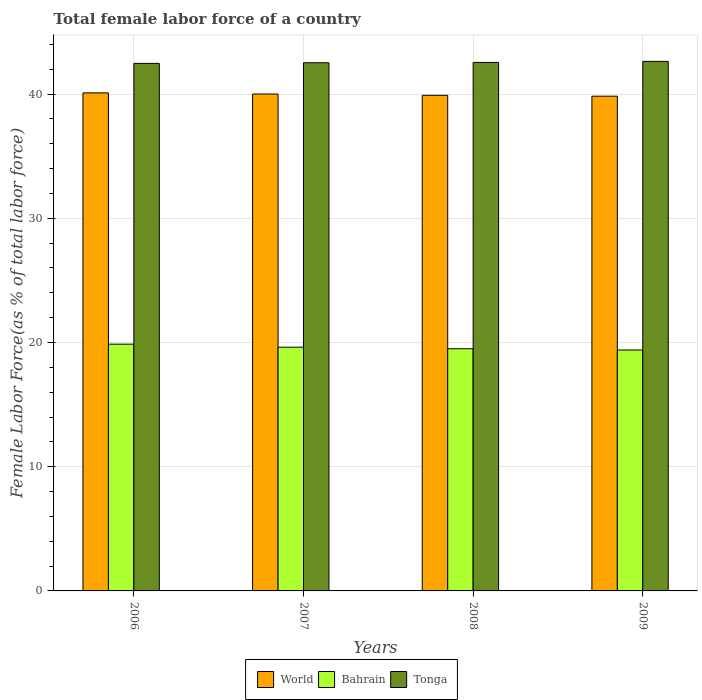How many different coloured bars are there?
Offer a terse response. 3. Are the number of bars per tick equal to the number of legend labels?
Make the answer very short. Yes. Are the number of bars on each tick of the X-axis equal?
Offer a terse response. Yes. How many bars are there on the 2nd tick from the right?
Your response must be concise. 3. What is the percentage of female labor force in Bahrain in 2009?
Give a very brief answer. 19.4. Across all years, what is the maximum percentage of female labor force in Bahrain?
Ensure brevity in your answer.  19.87. Across all years, what is the minimum percentage of female labor force in World?
Your response must be concise. 39.83. In which year was the percentage of female labor force in World minimum?
Your answer should be compact. 2009. What is the total percentage of female labor force in Bahrain in the graph?
Your answer should be compact. 78.38. What is the difference between the percentage of female labor force in Tonga in 2006 and that in 2009?
Give a very brief answer. -0.16. What is the difference between the percentage of female labor force in World in 2007 and the percentage of female labor force in Tonga in 2009?
Make the answer very short. -2.63. What is the average percentage of female labor force in World per year?
Your answer should be very brief. 39.96. In the year 2007, what is the difference between the percentage of female labor force in World and percentage of female labor force in Bahrain?
Ensure brevity in your answer.  20.38. What is the ratio of the percentage of female labor force in World in 2006 to that in 2009?
Provide a succinct answer. 1.01. Is the percentage of female labor force in Bahrain in 2007 less than that in 2008?
Your answer should be compact. No. Is the difference between the percentage of female labor force in World in 2006 and 2008 greater than the difference between the percentage of female labor force in Bahrain in 2006 and 2008?
Keep it short and to the point. No. What is the difference between the highest and the second highest percentage of female labor force in Bahrain?
Your response must be concise. 0.24. What is the difference between the highest and the lowest percentage of female labor force in World?
Offer a terse response. 0.27. What does the 3rd bar from the left in 2006 represents?
Ensure brevity in your answer.  Tonga. What does the 2nd bar from the right in 2008 represents?
Provide a short and direct response. Bahrain. Is it the case that in every year, the sum of the percentage of female labor force in Tonga and percentage of female labor force in Bahrain is greater than the percentage of female labor force in World?
Offer a very short reply. Yes. Does the graph contain any zero values?
Offer a terse response. No. Does the graph contain grids?
Provide a short and direct response. Yes. How are the legend labels stacked?
Your answer should be very brief. Horizontal. What is the title of the graph?
Provide a short and direct response. Total female labor force of a country. Does "Armenia" appear as one of the legend labels in the graph?
Provide a short and direct response. No. What is the label or title of the X-axis?
Keep it short and to the point. Years. What is the label or title of the Y-axis?
Your answer should be very brief. Female Labor Force(as % of total labor force). What is the Female Labor Force(as % of total labor force) in World in 2006?
Offer a very short reply. 40.1. What is the Female Labor Force(as % of total labor force) of Bahrain in 2006?
Ensure brevity in your answer.  19.87. What is the Female Labor Force(as % of total labor force) of Tonga in 2006?
Your answer should be compact. 42.47. What is the Female Labor Force(as % of total labor force) in World in 2007?
Keep it short and to the point. 40. What is the Female Labor Force(as % of total labor force) in Bahrain in 2007?
Make the answer very short. 19.62. What is the Female Labor Force(as % of total labor force) of Tonga in 2007?
Make the answer very short. 42.52. What is the Female Labor Force(as % of total labor force) in World in 2008?
Your answer should be compact. 39.9. What is the Female Labor Force(as % of total labor force) in Bahrain in 2008?
Give a very brief answer. 19.5. What is the Female Labor Force(as % of total labor force) in Tonga in 2008?
Offer a very short reply. 42.55. What is the Female Labor Force(as % of total labor force) of World in 2009?
Your answer should be very brief. 39.83. What is the Female Labor Force(as % of total labor force) in Bahrain in 2009?
Offer a terse response. 19.4. What is the Female Labor Force(as % of total labor force) in Tonga in 2009?
Offer a very short reply. 42.63. Across all years, what is the maximum Female Labor Force(as % of total labor force) in World?
Your answer should be compact. 40.1. Across all years, what is the maximum Female Labor Force(as % of total labor force) in Bahrain?
Offer a terse response. 19.87. Across all years, what is the maximum Female Labor Force(as % of total labor force) in Tonga?
Provide a succinct answer. 42.63. Across all years, what is the minimum Female Labor Force(as % of total labor force) of World?
Offer a very short reply. 39.83. Across all years, what is the minimum Female Labor Force(as % of total labor force) in Bahrain?
Ensure brevity in your answer.  19.4. Across all years, what is the minimum Female Labor Force(as % of total labor force) in Tonga?
Keep it short and to the point. 42.47. What is the total Female Labor Force(as % of total labor force) in World in the graph?
Offer a terse response. 159.83. What is the total Female Labor Force(as % of total labor force) of Bahrain in the graph?
Ensure brevity in your answer.  78.38. What is the total Female Labor Force(as % of total labor force) in Tonga in the graph?
Ensure brevity in your answer.  170.17. What is the difference between the Female Labor Force(as % of total labor force) of World in 2006 and that in 2007?
Offer a very short reply. 0.09. What is the difference between the Female Labor Force(as % of total labor force) in Bahrain in 2006 and that in 2007?
Make the answer very short. 0.24. What is the difference between the Female Labor Force(as % of total labor force) of Tonga in 2006 and that in 2007?
Your answer should be compact. -0.05. What is the difference between the Female Labor Force(as % of total labor force) in World in 2006 and that in 2008?
Keep it short and to the point. 0.2. What is the difference between the Female Labor Force(as % of total labor force) of Bahrain in 2006 and that in 2008?
Offer a very short reply. 0.37. What is the difference between the Female Labor Force(as % of total labor force) of Tonga in 2006 and that in 2008?
Your answer should be very brief. -0.08. What is the difference between the Female Labor Force(as % of total labor force) of World in 2006 and that in 2009?
Give a very brief answer. 0.27. What is the difference between the Female Labor Force(as % of total labor force) of Bahrain in 2006 and that in 2009?
Provide a succinct answer. 0.47. What is the difference between the Female Labor Force(as % of total labor force) of Tonga in 2006 and that in 2009?
Provide a succinct answer. -0.16. What is the difference between the Female Labor Force(as % of total labor force) of World in 2007 and that in 2008?
Offer a terse response. 0.1. What is the difference between the Female Labor Force(as % of total labor force) in Bahrain in 2007 and that in 2008?
Keep it short and to the point. 0.13. What is the difference between the Female Labor Force(as % of total labor force) of Tonga in 2007 and that in 2008?
Make the answer very short. -0.02. What is the difference between the Female Labor Force(as % of total labor force) in World in 2007 and that in 2009?
Ensure brevity in your answer.  0.17. What is the difference between the Female Labor Force(as % of total labor force) in Bahrain in 2007 and that in 2009?
Your response must be concise. 0.23. What is the difference between the Female Labor Force(as % of total labor force) in Tonga in 2007 and that in 2009?
Provide a succinct answer. -0.11. What is the difference between the Female Labor Force(as % of total labor force) in World in 2008 and that in 2009?
Make the answer very short. 0.07. What is the difference between the Female Labor Force(as % of total labor force) in Bahrain in 2008 and that in 2009?
Give a very brief answer. 0.1. What is the difference between the Female Labor Force(as % of total labor force) in Tonga in 2008 and that in 2009?
Ensure brevity in your answer.  -0.09. What is the difference between the Female Labor Force(as % of total labor force) of World in 2006 and the Female Labor Force(as % of total labor force) of Bahrain in 2007?
Give a very brief answer. 20.47. What is the difference between the Female Labor Force(as % of total labor force) in World in 2006 and the Female Labor Force(as % of total labor force) in Tonga in 2007?
Provide a short and direct response. -2.43. What is the difference between the Female Labor Force(as % of total labor force) in Bahrain in 2006 and the Female Labor Force(as % of total labor force) in Tonga in 2007?
Make the answer very short. -22.66. What is the difference between the Female Labor Force(as % of total labor force) of World in 2006 and the Female Labor Force(as % of total labor force) of Bahrain in 2008?
Provide a succinct answer. 20.6. What is the difference between the Female Labor Force(as % of total labor force) in World in 2006 and the Female Labor Force(as % of total labor force) in Tonga in 2008?
Make the answer very short. -2.45. What is the difference between the Female Labor Force(as % of total labor force) of Bahrain in 2006 and the Female Labor Force(as % of total labor force) of Tonga in 2008?
Ensure brevity in your answer.  -22.68. What is the difference between the Female Labor Force(as % of total labor force) of World in 2006 and the Female Labor Force(as % of total labor force) of Bahrain in 2009?
Make the answer very short. 20.7. What is the difference between the Female Labor Force(as % of total labor force) of World in 2006 and the Female Labor Force(as % of total labor force) of Tonga in 2009?
Give a very brief answer. -2.54. What is the difference between the Female Labor Force(as % of total labor force) of Bahrain in 2006 and the Female Labor Force(as % of total labor force) of Tonga in 2009?
Provide a succinct answer. -22.77. What is the difference between the Female Labor Force(as % of total labor force) of World in 2007 and the Female Labor Force(as % of total labor force) of Bahrain in 2008?
Your answer should be compact. 20.51. What is the difference between the Female Labor Force(as % of total labor force) in World in 2007 and the Female Labor Force(as % of total labor force) in Tonga in 2008?
Offer a terse response. -2.54. What is the difference between the Female Labor Force(as % of total labor force) in Bahrain in 2007 and the Female Labor Force(as % of total labor force) in Tonga in 2008?
Your response must be concise. -22.92. What is the difference between the Female Labor Force(as % of total labor force) of World in 2007 and the Female Labor Force(as % of total labor force) of Bahrain in 2009?
Provide a succinct answer. 20.61. What is the difference between the Female Labor Force(as % of total labor force) of World in 2007 and the Female Labor Force(as % of total labor force) of Tonga in 2009?
Your answer should be compact. -2.63. What is the difference between the Female Labor Force(as % of total labor force) of Bahrain in 2007 and the Female Labor Force(as % of total labor force) of Tonga in 2009?
Give a very brief answer. -23.01. What is the difference between the Female Labor Force(as % of total labor force) in World in 2008 and the Female Labor Force(as % of total labor force) in Bahrain in 2009?
Make the answer very short. 20.5. What is the difference between the Female Labor Force(as % of total labor force) of World in 2008 and the Female Labor Force(as % of total labor force) of Tonga in 2009?
Ensure brevity in your answer.  -2.73. What is the difference between the Female Labor Force(as % of total labor force) of Bahrain in 2008 and the Female Labor Force(as % of total labor force) of Tonga in 2009?
Your response must be concise. -23.14. What is the average Female Labor Force(as % of total labor force) in World per year?
Offer a very short reply. 39.96. What is the average Female Labor Force(as % of total labor force) of Bahrain per year?
Your response must be concise. 19.6. What is the average Female Labor Force(as % of total labor force) of Tonga per year?
Offer a very short reply. 42.54. In the year 2006, what is the difference between the Female Labor Force(as % of total labor force) in World and Female Labor Force(as % of total labor force) in Bahrain?
Offer a very short reply. 20.23. In the year 2006, what is the difference between the Female Labor Force(as % of total labor force) in World and Female Labor Force(as % of total labor force) in Tonga?
Your response must be concise. -2.37. In the year 2006, what is the difference between the Female Labor Force(as % of total labor force) of Bahrain and Female Labor Force(as % of total labor force) of Tonga?
Your response must be concise. -22.6. In the year 2007, what is the difference between the Female Labor Force(as % of total labor force) of World and Female Labor Force(as % of total labor force) of Bahrain?
Provide a short and direct response. 20.38. In the year 2007, what is the difference between the Female Labor Force(as % of total labor force) in World and Female Labor Force(as % of total labor force) in Tonga?
Provide a short and direct response. -2.52. In the year 2007, what is the difference between the Female Labor Force(as % of total labor force) of Bahrain and Female Labor Force(as % of total labor force) of Tonga?
Keep it short and to the point. -22.9. In the year 2008, what is the difference between the Female Labor Force(as % of total labor force) of World and Female Labor Force(as % of total labor force) of Bahrain?
Your answer should be compact. 20.4. In the year 2008, what is the difference between the Female Labor Force(as % of total labor force) of World and Female Labor Force(as % of total labor force) of Tonga?
Offer a very short reply. -2.65. In the year 2008, what is the difference between the Female Labor Force(as % of total labor force) of Bahrain and Female Labor Force(as % of total labor force) of Tonga?
Provide a short and direct response. -23.05. In the year 2009, what is the difference between the Female Labor Force(as % of total labor force) of World and Female Labor Force(as % of total labor force) of Bahrain?
Your response must be concise. 20.43. In the year 2009, what is the difference between the Female Labor Force(as % of total labor force) in World and Female Labor Force(as % of total labor force) in Tonga?
Your response must be concise. -2.81. In the year 2009, what is the difference between the Female Labor Force(as % of total labor force) of Bahrain and Female Labor Force(as % of total labor force) of Tonga?
Ensure brevity in your answer.  -23.24. What is the ratio of the Female Labor Force(as % of total labor force) of World in 2006 to that in 2007?
Offer a very short reply. 1. What is the ratio of the Female Labor Force(as % of total labor force) of Bahrain in 2006 to that in 2007?
Make the answer very short. 1.01. What is the ratio of the Female Labor Force(as % of total labor force) in Tonga in 2006 to that in 2007?
Offer a very short reply. 1. What is the ratio of the Female Labor Force(as % of total labor force) in World in 2006 to that in 2008?
Provide a succinct answer. 1. What is the ratio of the Female Labor Force(as % of total labor force) of Bahrain in 2006 to that in 2008?
Your answer should be compact. 1.02. What is the ratio of the Female Labor Force(as % of total labor force) of Tonga in 2006 to that in 2008?
Provide a succinct answer. 1. What is the ratio of the Female Labor Force(as % of total labor force) in World in 2006 to that in 2009?
Keep it short and to the point. 1.01. What is the ratio of the Female Labor Force(as % of total labor force) of Bahrain in 2006 to that in 2009?
Your answer should be very brief. 1.02. What is the ratio of the Female Labor Force(as % of total labor force) of Tonga in 2006 to that in 2009?
Offer a very short reply. 1. What is the ratio of the Female Labor Force(as % of total labor force) of World in 2007 to that in 2008?
Keep it short and to the point. 1. What is the ratio of the Female Labor Force(as % of total labor force) in Bahrain in 2007 to that in 2008?
Your response must be concise. 1.01. What is the ratio of the Female Labor Force(as % of total labor force) in World in 2007 to that in 2009?
Provide a short and direct response. 1. What is the ratio of the Female Labor Force(as % of total labor force) in Bahrain in 2007 to that in 2009?
Provide a short and direct response. 1.01. What is the ratio of the Female Labor Force(as % of total labor force) of Tonga in 2007 to that in 2009?
Keep it short and to the point. 1. What is the ratio of the Female Labor Force(as % of total labor force) of Tonga in 2008 to that in 2009?
Your response must be concise. 1. What is the difference between the highest and the second highest Female Labor Force(as % of total labor force) of World?
Your answer should be compact. 0.09. What is the difference between the highest and the second highest Female Labor Force(as % of total labor force) of Bahrain?
Provide a short and direct response. 0.24. What is the difference between the highest and the second highest Female Labor Force(as % of total labor force) in Tonga?
Your answer should be very brief. 0.09. What is the difference between the highest and the lowest Female Labor Force(as % of total labor force) of World?
Ensure brevity in your answer.  0.27. What is the difference between the highest and the lowest Female Labor Force(as % of total labor force) of Bahrain?
Offer a terse response. 0.47. What is the difference between the highest and the lowest Female Labor Force(as % of total labor force) of Tonga?
Keep it short and to the point. 0.16. 